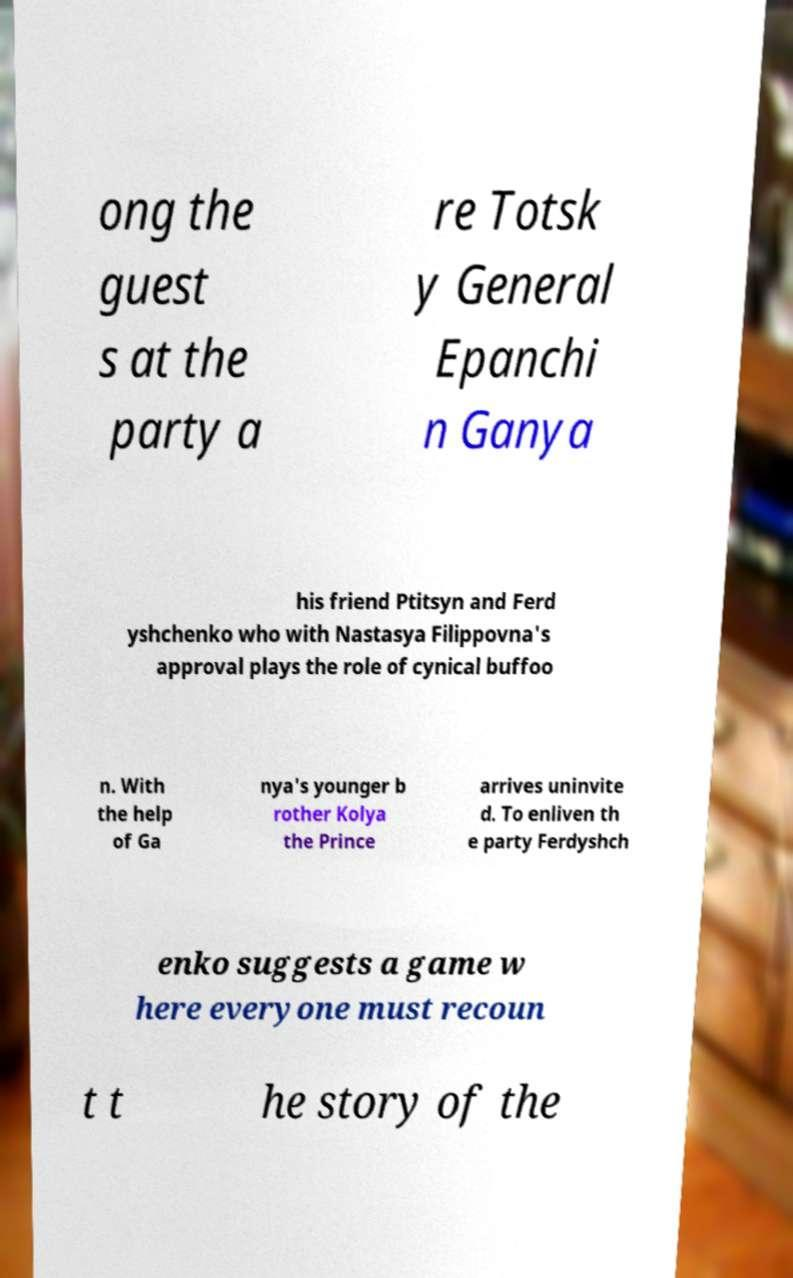What messages or text are displayed in this image? I need them in a readable, typed format. ong the guest s at the party a re Totsk y General Epanchi n Ganya his friend Ptitsyn and Ferd yshchenko who with Nastasya Filippovna's approval plays the role of cynical buffoo n. With the help of Ga nya's younger b rother Kolya the Prince arrives uninvite d. To enliven th e party Ferdyshch enko suggests a game w here everyone must recoun t t he story of the 